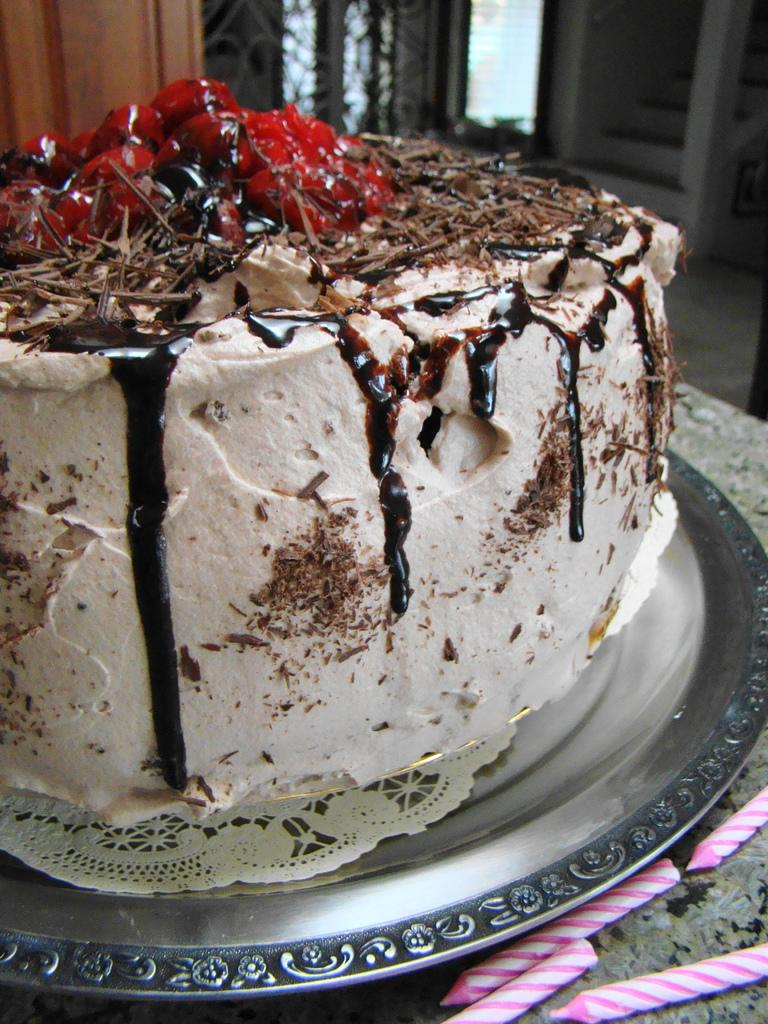What is on the plate in the image? There is a cake on a plate in the image. Where is the cake placed? The cake is on a surface. What is near the plate? There are candles near the plate. What can be seen in the background of the image? There are steps visible in the background of the image. How would you describe the background of the image? The background is blurry. Can you see a plough in the image? No, there is no plough present in the image. What type of skin is visible on the cake? There is no skin visible on the cake; it is a dessert item. 